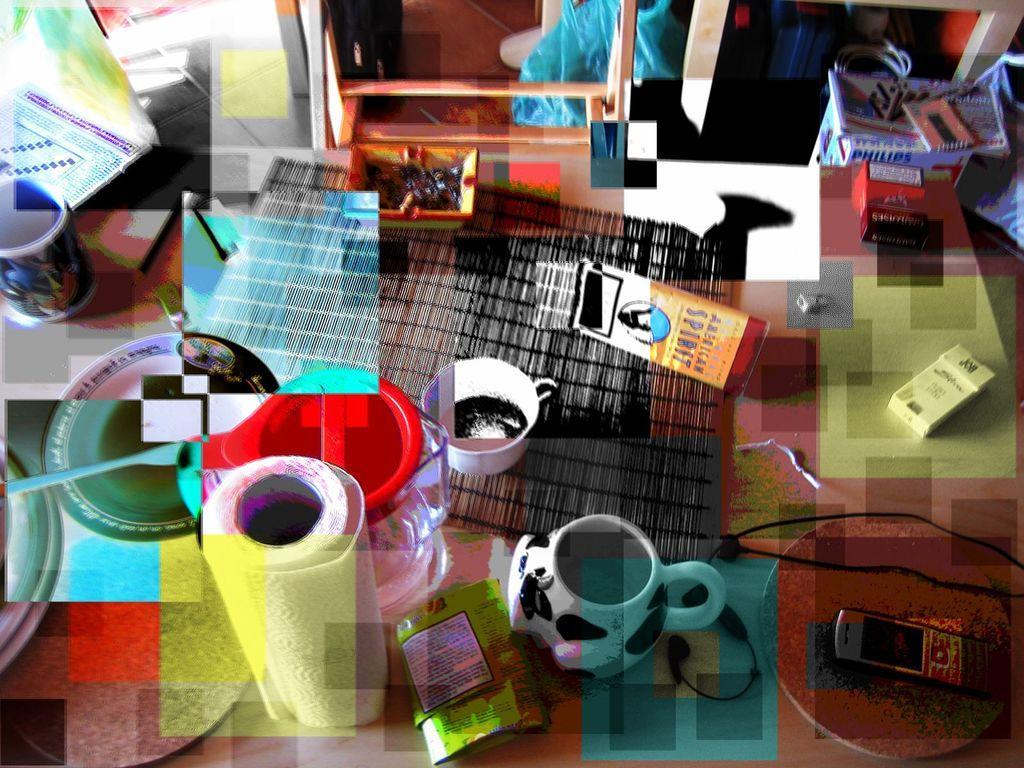How would you summarize this image in a sentence or two? In the image we can see a table, on the table we can see some cups, stamps, mobile phone, cigarette packets and some products. 